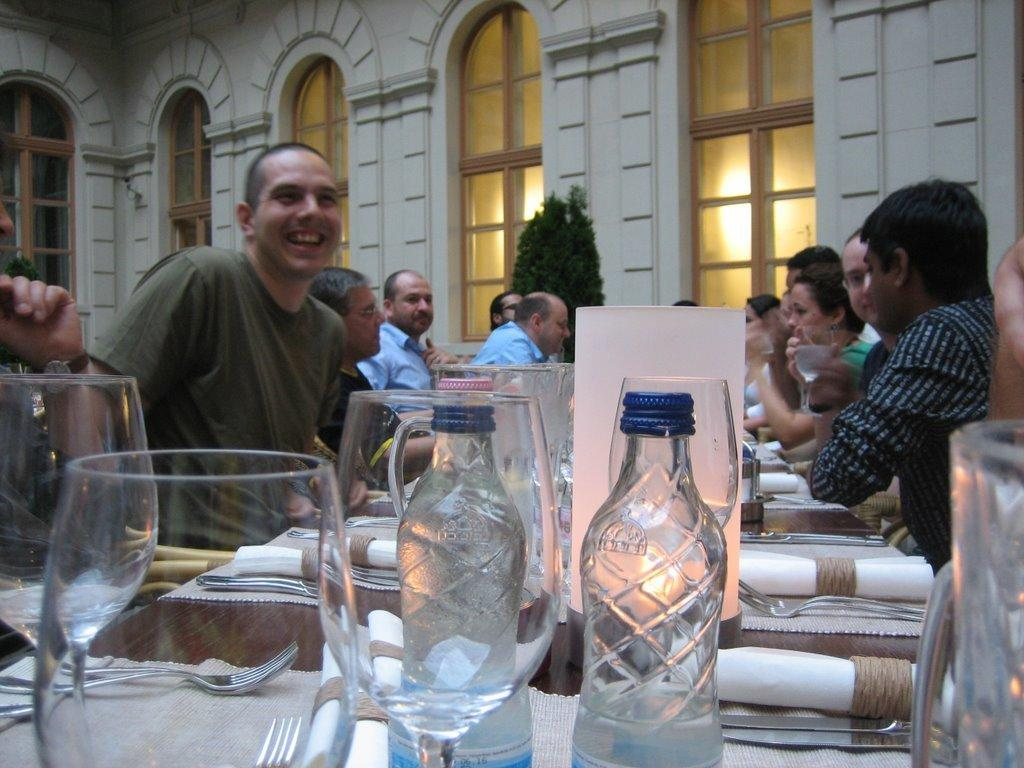How many people are sitting around the table in the image? There are many people sitting around the table in the image. What items can be seen on the table? There are bottles, wine glasses, forks, and a paper on the table. What type of building is depicted in the image? This is a building. Is there any greenery present in the image? Yes, there is a plant in the image. What type of parcel is being delivered to the building in the image? There is no parcel visible in the image, so it cannot be determined what type of parcel might be delivered. 